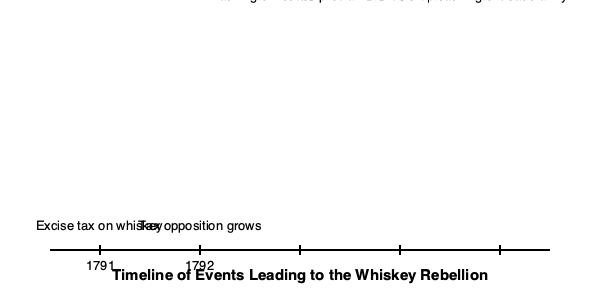Based on the timeline, what event directly preceded the outbreak of violence in the Whiskey Rebellion? To answer this question, we need to analyze the events on the timeline in chronological order:

1. 1791: The excise tax on whiskey is implemented, which is the initial cause of discontent.
2. 1792: Tax opposition grows among the populace, indicating rising tensions.
3. 1793: President Washington issues a proclamation, likely addressing the growing opposition.
4. 1794 (first event): Violence erupts, marking the beginning of the Whiskey Rebellion.
5. 1794 (second event): Washington leads an army to quell the rebellion.

The event that directly preceded the outbreak of violence in 1794 was Washington's proclamation in 1793. This proclamation was likely an attempt to address the growing opposition and prevent further escalation. However, it apparently did not succeed in calming the situation, as violence erupted the following year.
Answer: Washington's proclamation in 1793 